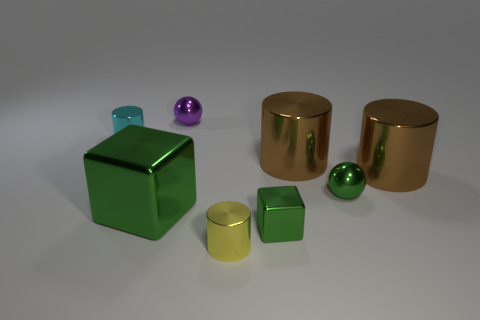Subtract all red cylinders. Subtract all green spheres. How many cylinders are left? 4 Add 1 large brown balls. How many objects exist? 9 Subtract all spheres. How many objects are left? 6 Subtract 1 green cubes. How many objects are left? 7 Subtract all tiny blue shiny cylinders. Subtract all big brown things. How many objects are left? 6 Add 7 tiny purple metal objects. How many tiny purple metal objects are left? 8 Add 4 small blue objects. How many small blue objects exist? 4 